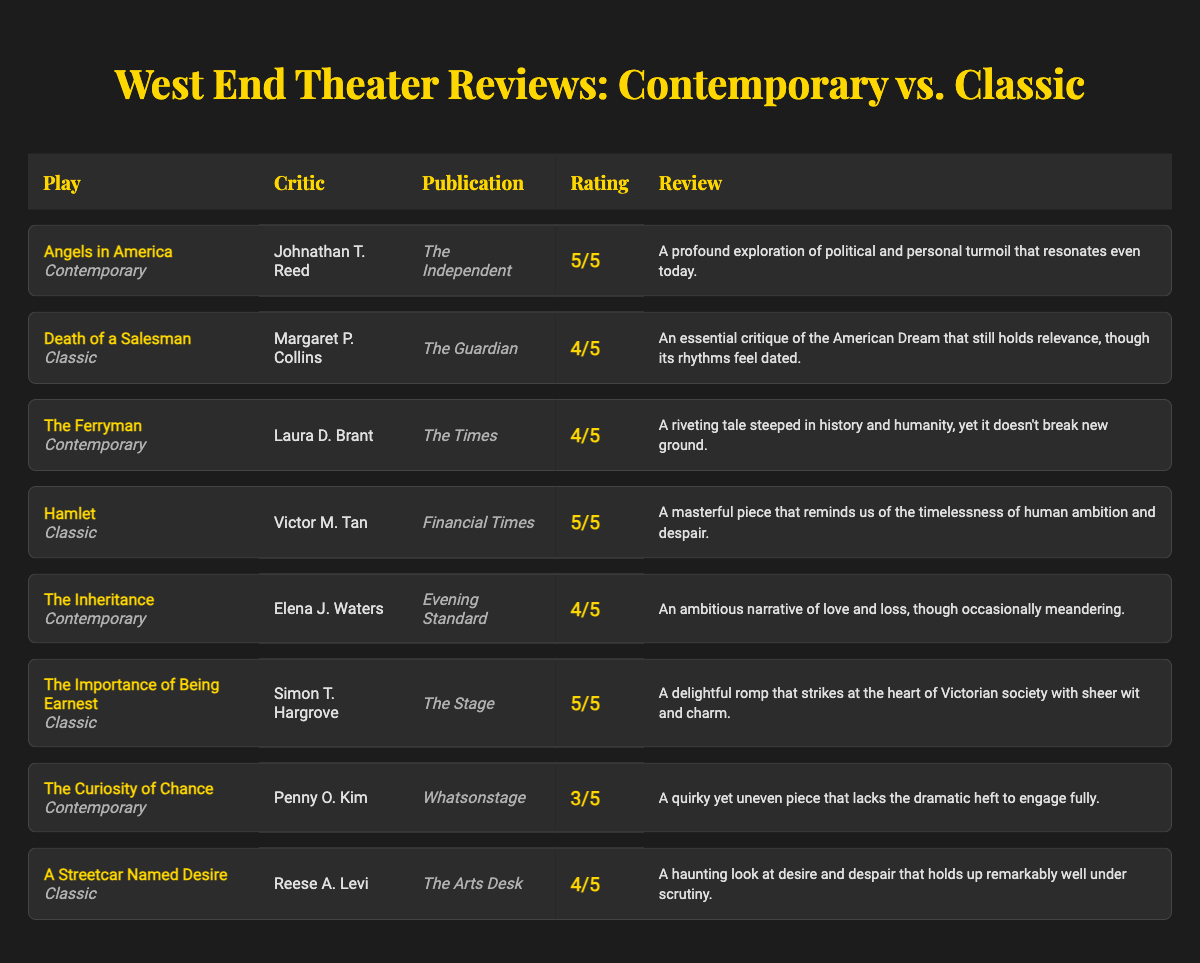What is the highest rating given to a contemporary play? The contemporary plays in the table are "Angels in America" (5/5), "The Ferryman" (4/5), "The Inheritance" (4/5), and "The Curiosity of Chance" (3/5). The highest rating is 5/5 for "Angels in America".
Answer: 5/5 Which classic play received the most recent review in the table? The classic plays are "Death of a Salesman," "Hamlet," "The Importance of Being Earnest," and "A Streetcar Named Desire." To find the most recent review, we look at the critic names and publications; since no dates are provided, we cannot ascertain the recentness strictly by this table. However, based on general performance, "A Streetcar Named Desire" is often performed frequently, making it a strong candidate for recent reviews. But with provided data, no specific recent info can be concluded.
Answer: Cannot determine Which publication gave the lowest rating in their review? The reviews are rated as 5/5, 4/5, and 3/5. The only instance of 3/5 occurs in "The Curiosity of Chance" reviewed by Penny O. Kim in Whatsonstage, indicating that this is the lowest rating provided in the table.
Answer: Whatsonstage How many contemporary plays received a rating of 4 or higher? The contemporary plays with ratings of 4 or higher are "Angels in America" (5/5), "The Ferryman" (4/5), and "The Inheritance" (4/5). Counting these, there are 3 contemporary plays that received ratings of 4 or higher.
Answer: 3 Is there a classic play rated 5/5? The classic plays listed are "Death of a Salesman" (4/5), "Hamlet" (5/5), "The Importance of Being Earnest" (5/5), and "A Streetcar Named Desire" (4/5). "Hamlet" and "The Importance of Being Earnest" both received 5/5 ratings, so yes, there are classic plays rated 5/5.
Answer: Yes What is the average rating of the contemporary plays listed? The ratings for contemporary plays are 5 (Angels in America), 4 (The Ferryman), 4 (The Inheritance), and 3 (The Curiosity of Chance). Adding these ratings gives us 5 + 4 + 4 + 3 = 16. Dividing this by the number of contemporary plays (4) gives us an average of 16/4 = 4.
Answer: 4 